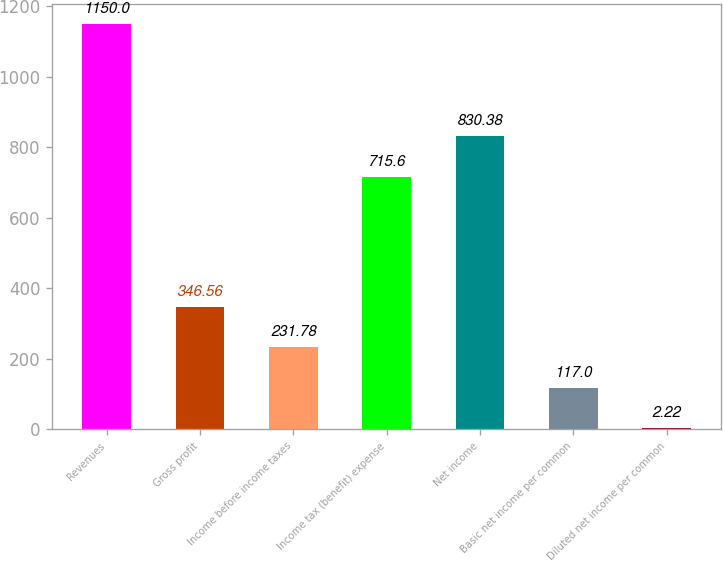<chart> <loc_0><loc_0><loc_500><loc_500><bar_chart><fcel>Revenues<fcel>Gross profit<fcel>Income before income taxes<fcel>Income tax (benefit) expense<fcel>Net income<fcel>Basic net income per common<fcel>Diluted net income per common<nl><fcel>1150<fcel>346.56<fcel>231.78<fcel>715.6<fcel>830.38<fcel>117<fcel>2.22<nl></chart> 